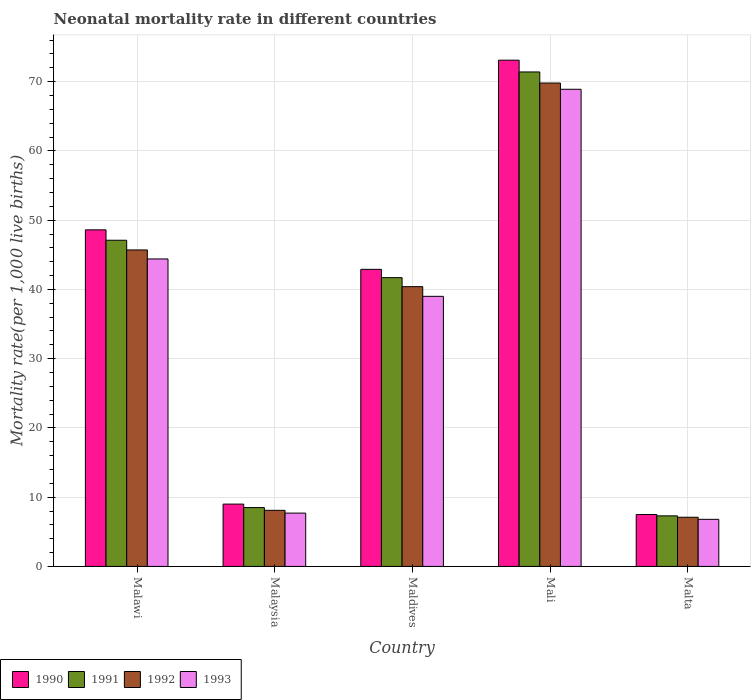How many groups of bars are there?
Your answer should be compact. 5. Are the number of bars per tick equal to the number of legend labels?
Ensure brevity in your answer.  Yes. How many bars are there on the 2nd tick from the left?
Offer a terse response. 4. How many bars are there on the 1st tick from the right?
Your answer should be very brief. 4. What is the label of the 2nd group of bars from the left?
Offer a terse response. Malaysia. What is the neonatal mortality rate in 1990 in Mali?
Your response must be concise. 73.1. Across all countries, what is the maximum neonatal mortality rate in 1990?
Make the answer very short. 73.1. In which country was the neonatal mortality rate in 1993 maximum?
Your answer should be compact. Mali. In which country was the neonatal mortality rate in 1991 minimum?
Ensure brevity in your answer.  Malta. What is the total neonatal mortality rate in 1992 in the graph?
Keep it short and to the point. 171.1. What is the difference between the neonatal mortality rate in 1990 in Malawi and that in Maldives?
Ensure brevity in your answer.  5.7. What is the difference between the neonatal mortality rate in 1991 in Maldives and the neonatal mortality rate in 1990 in Malaysia?
Keep it short and to the point. 32.7. What is the average neonatal mortality rate in 1992 per country?
Ensure brevity in your answer.  34.22. What is the difference between the neonatal mortality rate of/in 1990 and neonatal mortality rate of/in 1993 in Maldives?
Offer a terse response. 3.9. What is the ratio of the neonatal mortality rate in 1991 in Malawi to that in Malta?
Your response must be concise. 6.45. Is the difference between the neonatal mortality rate in 1990 in Malawi and Malaysia greater than the difference between the neonatal mortality rate in 1993 in Malawi and Malaysia?
Your answer should be very brief. Yes. What is the difference between the highest and the second highest neonatal mortality rate in 1992?
Your response must be concise. -5.3. What is the difference between the highest and the lowest neonatal mortality rate in 1991?
Provide a succinct answer. 64.1. In how many countries, is the neonatal mortality rate in 1991 greater than the average neonatal mortality rate in 1991 taken over all countries?
Offer a very short reply. 3. Is it the case that in every country, the sum of the neonatal mortality rate in 1991 and neonatal mortality rate in 1990 is greater than the sum of neonatal mortality rate in 1992 and neonatal mortality rate in 1993?
Your answer should be very brief. No. Is it the case that in every country, the sum of the neonatal mortality rate in 1990 and neonatal mortality rate in 1993 is greater than the neonatal mortality rate in 1992?
Ensure brevity in your answer.  Yes. How many bars are there?
Offer a very short reply. 20. Are the values on the major ticks of Y-axis written in scientific E-notation?
Your answer should be compact. No. Does the graph contain any zero values?
Your answer should be compact. No. Does the graph contain grids?
Your response must be concise. Yes. Where does the legend appear in the graph?
Give a very brief answer. Bottom left. What is the title of the graph?
Offer a very short reply. Neonatal mortality rate in different countries. Does "1997" appear as one of the legend labels in the graph?
Provide a short and direct response. No. What is the label or title of the X-axis?
Give a very brief answer. Country. What is the label or title of the Y-axis?
Offer a terse response. Mortality rate(per 1,0 live births). What is the Mortality rate(per 1,000 live births) in 1990 in Malawi?
Your answer should be compact. 48.6. What is the Mortality rate(per 1,000 live births) of 1991 in Malawi?
Provide a short and direct response. 47.1. What is the Mortality rate(per 1,000 live births) in 1992 in Malawi?
Make the answer very short. 45.7. What is the Mortality rate(per 1,000 live births) of 1993 in Malawi?
Ensure brevity in your answer.  44.4. What is the Mortality rate(per 1,000 live births) in 1990 in Malaysia?
Ensure brevity in your answer.  9. What is the Mortality rate(per 1,000 live births) of 1991 in Malaysia?
Keep it short and to the point. 8.5. What is the Mortality rate(per 1,000 live births) of 1993 in Malaysia?
Your answer should be compact. 7.7. What is the Mortality rate(per 1,000 live births) in 1990 in Maldives?
Your answer should be very brief. 42.9. What is the Mortality rate(per 1,000 live births) of 1991 in Maldives?
Offer a very short reply. 41.7. What is the Mortality rate(per 1,000 live births) in 1992 in Maldives?
Your response must be concise. 40.4. What is the Mortality rate(per 1,000 live births) of 1990 in Mali?
Offer a terse response. 73.1. What is the Mortality rate(per 1,000 live births) of 1991 in Mali?
Offer a very short reply. 71.4. What is the Mortality rate(per 1,000 live births) in 1992 in Mali?
Offer a terse response. 69.8. What is the Mortality rate(per 1,000 live births) of 1993 in Mali?
Offer a very short reply. 68.9. What is the Mortality rate(per 1,000 live births) in 1990 in Malta?
Offer a very short reply. 7.5. What is the Mortality rate(per 1,000 live births) in 1991 in Malta?
Ensure brevity in your answer.  7.3. What is the Mortality rate(per 1,000 live births) of 1993 in Malta?
Your response must be concise. 6.8. Across all countries, what is the maximum Mortality rate(per 1,000 live births) of 1990?
Your answer should be compact. 73.1. Across all countries, what is the maximum Mortality rate(per 1,000 live births) of 1991?
Your response must be concise. 71.4. Across all countries, what is the maximum Mortality rate(per 1,000 live births) in 1992?
Your response must be concise. 69.8. Across all countries, what is the maximum Mortality rate(per 1,000 live births) of 1993?
Offer a terse response. 68.9. Across all countries, what is the minimum Mortality rate(per 1,000 live births) of 1990?
Offer a terse response. 7.5. Across all countries, what is the minimum Mortality rate(per 1,000 live births) in 1991?
Provide a succinct answer. 7.3. What is the total Mortality rate(per 1,000 live births) of 1990 in the graph?
Offer a very short reply. 181.1. What is the total Mortality rate(per 1,000 live births) in 1991 in the graph?
Your answer should be compact. 176. What is the total Mortality rate(per 1,000 live births) of 1992 in the graph?
Provide a short and direct response. 171.1. What is the total Mortality rate(per 1,000 live births) in 1993 in the graph?
Offer a terse response. 166.8. What is the difference between the Mortality rate(per 1,000 live births) in 1990 in Malawi and that in Malaysia?
Provide a short and direct response. 39.6. What is the difference between the Mortality rate(per 1,000 live births) in 1991 in Malawi and that in Malaysia?
Your answer should be compact. 38.6. What is the difference between the Mortality rate(per 1,000 live births) of 1992 in Malawi and that in Malaysia?
Provide a succinct answer. 37.6. What is the difference between the Mortality rate(per 1,000 live births) of 1993 in Malawi and that in Malaysia?
Your answer should be compact. 36.7. What is the difference between the Mortality rate(per 1,000 live births) in 1990 in Malawi and that in Maldives?
Your response must be concise. 5.7. What is the difference between the Mortality rate(per 1,000 live births) of 1991 in Malawi and that in Maldives?
Make the answer very short. 5.4. What is the difference between the Mortality rate(per 1,000 live births) in 1992 in Malawi and that in Maldives?
Ensure brevity in your answer.  5.3. What is the difference between the Mortality rate(per 1,000 live births) of 1990 in Malawi and that in Mali?
Offer a very short reply. -24.5. What is the difference between the Mortality rate(per 1,000 live births) of 1991 in Malawi and that in Mali?
Your answer should be compact. -24.3. What is the difference between the Mortality rate(per 1,000 live births) of 1992 in Malawi and that in Mali?
Ensure brevity in your answer.  -24.1. What is the difference between the Mortality rate(per 1,000 live births) of 1993 in Malawi and that in Mali?
Ensure brevity in your answer.  -24.5. What is the difference between the Mortality rate(per 1,000 live births) of 1990 in Malawi and that in Malta?
Ensure brevity in your answer.  41.1. What is the difference between the Mortality rate(per 1,000 live births) in 1991 in Malawi and that in Malta?
Give a very brief answer. 39.8. What is the difference between the Mortality rate(per 1,000 live births) in 1992 in Malawi and that in Malta?
Offer a very short reply. 38.6. What is the difference between the Mortality rate(per 1,000 live births) in 1993 in Malawi and that in Malta?
Offer a terse response. 37.6. What is the difference between the Mortality rate(per 1,000 live births) of 1990 in Malaysia and that in Maldives?
Ensure brevity in your answer.  -33.9. What is the difference between the Mortality rate(per 1,000 live births) in 1991 in Malaysia and that in Maldives?
Make the answer very short. -33.2. What is the difference between the Mortality rate(per 1,000 live births) of 1992 in Malaysia and that in Maldives?
Make the answer very short. -32.3. What is the difference between the Mortality rate(per 1,000 live births) in 1993 in Malaysia and that in Maldives?
Keep it short and to the point. -31.3. What is the difference between the Mortality rate(per 1,000 live births) in 1990 in Malaysia and that in Mali?
Your answer should be very brief. -64.1. What is the difference between the Mortality rate(per 1,000 live births) of 1991 in Malaysia and that in Mali?
Ensure brevity in your answer.  -62.9. What is the difference between the Mortality rate(per 1,000 live births) of 1992 in Malaysia and that in Mali?
Give a very brief answer. -61.7. What is the difference between the Mortality rate(per 1,000 live births) of 1993 in Malaysia and that in Mali?
Your answer should be very brief. -61.2. What is the difference between the Mortality rate(per 1,000 live births) of 1990 in Malaysia and that in Malta?
Ensure brevity in your answer.  1.5. What is the difference between the Mortality rate(per 1,000 live births) of 1992 in Malaysia and that in Malta?
Provide a short and direct response. 1. What is the difference between the Mortality rate(per 1,000 live births) of 1993 in Malaysia and that in Malta?
Your answer should be very brief. 0.9. What is the difference between the Mortality rate(per 1,000 live births) in 1990 in Maldives and that in Mali?
Ensure brevity in your answer.  -30.2. What is the difference between the Mortality rate(per 1,000 live births) in 1991 in Maldives and that in Mali?
Keep it short and to the point. -29.7. What is the difference between the Mortality rate(per 1,000 live births) in 1992 in Maldives and that in Mali?
Make the answer very short. -29.4. What is the difference between the Mortality rate(per 1,000 live births) of 1993 in Maldives and that in Mali?
Make the answer very short. -29.9. What is the difference between the Mortality rate(per 1,000 live births) of 1990 in Maldives and that in Malta?
Keep it short and to the point. 35.4. What is the difference between the Mortality rate(per 1,000 live births) of 1991 in Maldives and that in Malta?
Make the answer very short. 34.4. What is the difference between the Mortality rate(per 1,000 live births) of 1992 in Maldives and that in Malta?
Offer a terse response. 33.3. What is the difference between the Mortality rate(per 1,000 live births) of 1993 in Maldives and that in Malta?
Your response must be concise. 32.2. What is the difference between the Mortality rate(per 1,000 live births) in 1990 in Mali and that in Malta?
Offer a very short reply. 65.6. What is the difference between the Mortality rate(per 1,000 live births) in 1991 in Mali and that in Malta?
Offer a very short reply. 64.1. What is the difference between the Mortality rate(per 1,000 live births) of 1992 in Mali and that in Malta?
Provide a short and direct response. 62.7. What is the difference between the Mortality rate(per 1,000 live births) of 1993 in Mali and that in Malta?
Provide a short and direct response. 62.1. What is the difference between the Mortality rate(per 1,000 live births) of 1990 in Malawi and the Mortality rate(per 1,000 live births) of 1991 in Malaysia?
Give a very brief answer. 40.1. What is the difference between the Mortality rate(per 1,000 live births) in 1990 in Malawi and the Mortality rate(per 1,000 live births) in 1992 in Malaysia?
Your answer should be compact. 40.5. What is the difference between the Mortality rate(per 1,000 live births) in 1990 in Malawi and the Mortality rate(per 1,000 live births) in 1993 in Malaysia?
Offer a terse response. 40.9. What is the difference between the Mortality rate(per 1,000 live births) of 1991 in Malawi and the Mortality rate(per 1,000 live births) of 1993 in Malaysia?
Your answer should be very brief. 39.4. What is the difference between the Mortality rate(per 1,000 live births) in 1992 in Malawi and the Mortality rate(per 1,000 live births) in 1993 in Malaysia?
Your answer should be compact. 38. What is the difference between the Mortality rate(per 1,000 live births) of 1990 in Malawi and the Mortality rate(per 1,000 live births) of 1992 in Maldives?
Ensure brevity in your answer.  8.2. What is the difference between the Mortality rate(per 1,000 live births) of 1990 in Malawi and the Mortality rate(per 1,000 live births) of 1993 in Maldives?
Your answer should be compact. 9.6. What is the difference between the Mortality rate(per 1,000 live births) in 1990 in Malawi and the Mortality rate(per 1,000 live births) in 1991 in Mali?
Offer a terse response. -22.8. What is the difference between the Mortality rate(per 1,000 live births) of 1990 in Malawi and the Mortality rate(per 1,000 live births) of 1992 in Mali?
Your answer should be very brief. -21.2. What is the difference between the Mortality rate(per 1,000 live births) in 1990 in Malawi and the Mortality rate(per 1,000 live births) in 1993 in Mali?
Your answer should be very brief. -20.3. What is the difference between the Mortality rate(per 1,000 live births) in 1991 in Malawi and the Mortality rate(per 1,000 live births) in 1992 in Mali?
Ensure brevity in your answer.  -22.7. What is the difference between the Mortality rate(per 1,000 live births) of 1991 in Malawi and the Mortality rate(per 1,000 live births) of 1993 in Mali?
Give a very brief answer. -21.8. What is the difference between the Mortality rate(per 1,000 live births) in 1992 in Malawi and the Mortality rate(per 1,000 live births) in 1993 in Mali?
Offer a terse response. -23.2. What is the difference between the Mortality rate(per 1,000 live births) of 1990 in Malawi and the Mortality rate(per 1,000 live births) of 1991 in Malta?
Ensure brevity in your answer.  41.3. What is the difference between the Mortality rate(per 1,000 live births) of 1990 in Malawi and the Mortality rate(per 1,000 live births) of 1992 in Malta?
Provide a short and direct response. 41.5. What is the difference between the Mortality rate(per 1,000 live births) of 1990 in Malawi and the Mortality rate(per 1,000 live births) of 1993 in Malta?
Make the answer very short. 41.8. What is the difference between the Mortality rate(per 1,000 live births) in 1991 in Malawi and the Mortality rate(per 1,000 live births) in 1993 in Malta?
Your response must be concise. 40.3. What is the difference between the Mortality rate(per 1,000 live births) in 1992 in Malawi and the Mortality rate(per 1,000 live births) in 1993 in Malta?
Make the answer very short. 38.9. What is the difference between the Mortality rate(per 1,000 live births) in 1990 in Malaysia and the Mortality rate(per 1,000 live births) in 1991 in Maldives?
Provide a succinct answer. -32.7. What is the difference between the Mortality rate(per 1,000 live births) in 1990 in Malaysia and the Mortality rate(per 1,000 live births) in 1992 in Maldives?
Make the answer very short. -31.4. What is the difference between the Mortality rate(per 1,000 live births) of 1991 in Malaysia and the Mortality rate(per 1,000 live births) of 1992 in Maldives?
Your answer should be very brief. -31.9. What is the difference between the Mortality rate(per 1,000 live births) in 1991 in Malaysia and the Mortality rate(per 1,000 live births) in 1993 in Maldives?
Your answer should be very brief. -30.5. What is the difference between the Mortality rate(per 1,000 live births) in 1992 in Malaysia and the Mortality rate(per 1,000 live births) in 1993 in Maldives?
Offer a very short reply. -30.9. What is the difference between the Mortality rate(per 1,000 live births) in 1990 in Malaysia and the Mortality rate(per 1,000 live births) in 1991 in Mali?
Your response must be concise. -62.4. What is the difference between the Mortality rate(per 1,000 live births) in 1990 in Malaysia and the Mortality rate(per 1,000 live births) in 1992 in Mali?
Your answer should be very brief. -60.8. What is the difference between the Mortality rate(per 1,000 live births) in 1990 in Malaysia and the Mortality rate(per 1,000 live births) in 1993 in Mali?
Give a very brief answer. -59.9. What is the difference between the Mortality rate(per 1,000 live births) of 1991 in Malaysia and the Mortality rate(per 1,000 live births) of 1992 in Mali?
Provide a short and direct response. -61.3. What is the difference between the Mortality rate(per 1,000 live births) of 1991 in Malaysia and the Mortality rate(per 1,000 live births) of 1993 in Mali?
Provide a short and direct response. -60.4. What is the difference between the Mortality rate(per 1,000 live births) in 1992 in Malaysia and the Mortality rate(per 1,000 live births) in 1993 in Mali?
Make the answer very short. -60.8. What is the difference between the Mortality rate(per 1,000 live births) of 1991 in Malaysia and the Mortality rate(per 1,000 live births) of 1993 in Malta?
Keep it short and to the point. 1.7. What is the difference between the Mortality rate(per 1,000 live births) of 1992 in Malaysia and the Mortality rate(per 1,000 live births) of 1993 in Malta?
Your answer should be compact. 1.3. What is the difference between the Mortality rate(per 1,000 live births) of 1990 in Maldives and the Mortality rate(per 1,000 live births) of 1991 in Mali?
Give a very brief answer. -28.5. What is the difference between the Mortality rate(per 1,000 live births) in 1990 in Maldives and the Mortality rate(per 1,000 live births) in 1992 in Mali?
Ensure brevity in your answer.  -26.9. What is the difference between the Mortality rate(per 1,000 live births) of 1990 in Maldives and the Mortality rate(per 1,000 live births) of 1993 in Mali?
Offer a very short reply. -26. What is the difference between the Mortality rate(per 1,000 live births) of 1991 in Maldives and the Mortality rate(per 1,000 live births) of 1992 in Mali?
Your response must be concise. -28.1. What is the difference between the Mortality rate(per 1,000 live births) of 1991 in Maldives and the Mortality rate(per 1,000 live births) of 1993 in Mali?
Ensure brevity in your answer.  -27.2. What is the difference between the Mortality rate(per 1,000 live births) of 1992 in Maldives and the Mortality rate(per 1,000 live births) of 1993 in Mali?
Your answer should be compact. -28.5. What is the difference between the Mortality rate(per 1,000 live births) in 1990 in Maldives and the Mortality rate(per 1,000 live births) in 1991 in Malta?
Offer a very short reply. 35.6. What is the difference between the Mortality rate(per 1,000 live births) in 1990 in Maldives and the Mortality rate(per 1,000 live births) in 1992 in Malta?
Your answer should be compact. 35.8. What is the difference between the Mortality rate(per 1,000 live births) in 1990 in Maldives and the Mortality rate(per 1,000 live births) in 1993 in Malta?
Give a very brief answer. 36.1. What is the difference between the Mortality rate(per 1,000 live births) in 1991 in Maldives and the Mortality rate(per 1,000 live births) in 1992 in Malta?
Make the answer very short. 34.6. What is the difference between the Mortality rate(per 1,000 live births) in 1991 in Maldives and the Mortality rate(per 1,000 live births) in 1993 in Malta?
Ensure brevity in your answer.  34.9. What is the difference between the Mortality rate(per 1,000 live births) in 1992 in Maldives and the Mortality rate(per 1,000 live births) in 1993 in Malta?
Provide a short and direct response. 33.6. What is the difference between the Mortality rate(per 1,000 live births) in 1990 in Mali and the Mortality rate(per 1,000 live births) in 1991 in Malta?
Give a very brief answer. 65.8. What is the difference between the Mortality rate(per 1,000 live births) of 1990 in Mali and the Mortality rate(per 1,000 live births) of 1993 in Malta?
Offer a very short reply. 66.3. What is the difference between the Mortality rate(per 1,000 live births) in 1991 in Mali and the Mortality rate(per 1,000 live births) in 1992 in Malta?
Offer a terse response. 64.3. What is the difference between the Mortality rate(per 1,000 live births) of 1991 in Mali and the Mortality rate(per 1,000 live births) of 1993 in Malta?
Keep it short and to the point. 64.6. What is the difference between the Mortality rate(per 1,000 live births) of 1992 in Mali and the Mortality rate(per 1,000 live births) of 1993 in Malta?
Provide a short and direct response. 63. What is the average Mortality rate(per 1,000 live births) of 1990 per country?
Provide a succinct answer. 36.22. What is the average Mortality rate(per 1,000 live births) in 1991 per country?
Give a very brief answer. 35.2. What is the average Mortality rate(per 1,000 live births) in 1992 per country?
Keep it short and to the point. 34.22. What is the average Mortality rate(per 1,000 live births) in 1993 per country?
Your answer should be compact. 33.36. What is the difference between the Mortality rate(per 1,000 live births) of 1991 and Mortality rate(per 1,000 live births) of 1992 in Malawi?
Your answer should be very brief. 1.4. What is the difference between the Mortality rate(per 1,000 live births) of 1991 and Mortality rate(per 1,000 live births) of 1993 in Malawi?
Provide a short and direct response. 2.7. What is the difference between the Mortality rate(per 1,000 live births) in 1992 and Mortality rate(per 1,000 live births) in 1993 in Malawi?
Give a very brief answer. 1.3. What is the difference between the Mortality rate(per 1,000 live births) in 1990 and Mortality rate(per 1,000 live births) in 1991 in Malaysia?
Give a very brief answer. 0.5. What is the difference between the Mortality rate(per 1,000 live births) of 1990 and Mortality rate(per 1,000 live births) of 1993 in Malaysia?
Your answer should be compact. 1.3. What is the difference between the Mortality rate(per 1,000 live births) of 1991 and Mortality rate(per 1,000 live births) of 1992 in Malaysia?
Make the answer very short. 0.4. What is the difference between the Mortality rate(per 1,000 live births) of 1991 and Mortality rate(per 1,000 live births) of 1993 in Malaysia?
Your response must be concise. 0.8. What is the difference between the Mortality rate(per 1,000 live births) in 1992 and Mortality rate(per 1,000 live births) in 1993 in Malaysia?
Your answer should be very brief. 0.4. What is the difference between the Mortality rate(per 1,000 live births) of 1990 and Mortality rate(per 1,000 live births) of 1991 in Maldives?
Keep it short and to the point. 1.2. What is the difference between the Mortality rate(per 1,000 live births) in 1991 and Mortality rate(per 1,000 live births) in 1993 in Maldives?
Keep it short and to the point. 2.7. What is the difference between the Mortality rate(per 1,000 live births) of 1990 and Mortality rate(per 1,000 live births) of 1991 in Mali?
Ensure brevity in your answer.  1.7. What is the difference between the Mortality rate(per 1,000 live births) of 1991 and Mortality rate(per 1,000 live births) of 1992 in Mali?
Your answer should be compact. 1.6. What is the difference between the Mortality rate(per 1,000 live births) of 1991 and Mortality rate(per 1,000 live births) of 1993 in Mali?
Your response must be concise. 2.5. What is the difference between the Mortality rate(per 1,000 live births) in 1992 and Mortality rate(per 1,000 live births) in 1993 in Mali?
Give a very brief answer. 0.9. What is the difference between the Mortality rate(per 1,000 live births) of 1991 and Mortality rate(per 1,000 live births) of 1992 in Malta?
Make the answer very short. 0.2. What is the difference between the Mortality rate(per 1,000 live births) of 1991 and Mortality rate(per 1,000 live births) of 1993 in Malta?
Give a very brief answer. 0.5. What is the ratio of the Mortality rate(per 1,000 live births) of 1991 in Malawi to that in Malaysia?
Make the answer very short. 5.54. What is the ratio of the Mortality rate(per 1,000 live births) of 1992 in Malawi to that in Malaysia?
Your answer should be compact. 5.64. What is the ratio of the Mortality rate(per 1,000 live births) of 1993 in Malawi to that in Malaysia?
Provide a succinct answer. 5.77. What is the ratio of the Mortality rate(per 1,000 live births) in 1990 in Malawi to that in Maldives?
Keep it short and to the point. 1.13. What is the ratio of the Mortality rate(per 1,000 live births) of 1991 in Malawi to that in Maldives?
Provide a succinct answer. 1.13. What is the ratio of the Mortality rate(per 1,000 live births) in 1992 in Malawi to that in Maldives?
Provide a succinct answer. 1.13. What is the ratio of the Mortality rate(per 1,000 live births) of 1993 in Malawi to that in Maldives?
Your response must be concise. 1.14. What is the ratio of the Mortality rate(per 1,000 live births) of 1990 in Malawi to that in Mali?
Make the answer very short. 0.66. What is the ratio of the Mortality rate(per 1,000 live births) in 1991 in Malawi to that in Mali?
Give a very brief answer. 0.66. What is the ratio of the Mortality rate(per 1,000 live births) in 1992 in Malawi to that in Mali?
Your answer should be very brief. 0.65. What is the ratio of the Mortality rate(per 1,000 live births) in 1993 in Malawi to that in Mali?
Give a very brief answer. 0.64. What is the ratio of the Mortality rate(per 1,000 live births) in 1990 in Malawi to that in Malta?
Your answer should be very brief. 6.48. What is the ratio of the Mortality rate(per 1,000 live births) of 1991 in Malawi to that in Malta?
Make the answer very short. 6.45. What is the ratio of the Mortality rate(per 1,000 live births) in 1992 in Malawi to that in Malta?
Give a very brief answer. 6.44. What is the ratio of the Mortality rate(per 1,000 live births) in 1993 in Malawi to that in Malta?
Provide a short and direct response. 6.53. What is the ratio of the Mortality rate(per 1,000 live births) of 1990 in Malaysia to that in Maldives?
Give a very brief answer. 0.21. What is the ratio of the Mortality rate(per 1,000 live births) of 1991 in Malaysia to that in Maldives?
Keep it short and to the point. 0.2. What is the ratio of the Mortality rate(per 1,000 live births) of 1992 in Malaysia to that in Maldives?
Provide a short and direct response. 0.2. What is the ratio of the Mortality rate(per 1,000 live births) in 1993 in Malaysia to that in Maldives?
Provide a succinct answer. 0.2. What is the ratio of the Mortality rate(per 1,000 live births) in 1990 in Malaysia to that in Mali?
Provide a short and direct response. 0.12. What is the ratio of the Mortality rate(per 1,000 live births) in 1991 in Malaysia to that in Mali?
Ensure brevity in your answer.  0.12. What is the ratio of the Mortality rate(per 1,000 live births) of 1992 in Malaysia to that in Mali?
Keep it short and to the point. 0.12. What is the ratio of the Mortality rate(per 1,000 live births) in 1993 in Malaysia to that in Mali?
Offer a terse response. 0.11. What is the ratio of the Mortality rate(per 1,000 live births) in 1990 in Malaysia to that in Malta?
Your response must be concise. 1.2. What is the ratio of the Mortality rate(per 1,000 live births) of 1991 in Malaysia to that in Malta?
Make the answer very short. 1.16. What is the ratio of the Mortality rate(per 1,000 live births) in 1992 in Malaysia to that in Malta?
Make the answer very short. 1.14. What is the ratio of the Mortality rate(per 1,000 live births) of 1993 in Malaysia to that in Malta?
Provide a succinct answer. 1.13. What is the ratio of the Mortality rate(per 1,000 live births) of 1990 in Maldives to that in Mali?
Your response must be concise. 0.59. What is the ratio of the Mortality rate(per 1,000 live births) in 1991 in Maldives to that in Mali?
Provide a short and direct response. 0.58. What is the ratio of the Mortality rate(per 1,000 live births) in 1992 in Maldives to that in Mali?
Your answer should be very brief. 0.58. What is the ratio of the Mortality rate(per 1,000 live births) in 1993 in Maldives to that in Mali?
Your response must be concise. 0.57. What is the ratio of the Mortality rate(per 1,000 live births) in 1990 in Maldives to that in Malta?
Your answer should be very brief. 5.72. What is the ratio of the Mortality rate(per 1,000 live births) in 1991 in Maldives to that in Malta?
Your answer should be compact. 5.71. What is the ratio of the Mortality rate(per 1,000 live births) of 1992 in Maldives to that in Malta?
Make the answer very short. 5.69. What is the ratio of the Mortality rate(per 1,000 live births) in 1993 in Maldives to that in Malta?
Give a very brief answer. 5.74. What is the ratio of the Mortality rate(per 1,000 live births) in 1990 in Mali to that in Malta?
Offer a terse response. 9.75. What is the ratio of the Mortality rate(per 1,000 live births) in 1991 in Mali to that in Malta?
Offer a very short reply. 9.78. What is the ratio of the Mortality rate(per 1,000 live births) of 1992 in Mali to that in Malta?
Keep it short and to the point. 9.83. What is the ratio of the Mortality rate(per 1,000 live births) in 1993 in Mali to that in Malta?
Ensure brevity in your answer.  10.13. What is the difference between the highest and the second highest Mortality rate(per 1,000 live births) in 1991?
Provide a short and direct response. 24.3. What is the difference between the highest and the second highest Mortality rate(per 1,000 live births) in 1992?
Ensure brevity in your answer.  24.1. What is the difference between the highest and the lowest Mortality rate(per 1,000 live births) in 1990?
Ensure brevity in your answer.  65.6. What is the difference between the highest and the lowest Mortality rate(per 1,000 live births) in 1991?
Your answer should be compact. 64.1. What is the difference between the highest and the lowest Mortality rate(per 1,000 live births) of 1992?
Provide a short and direct response. 62.7. What is the difference between the highest and the lowest Mortality rate(per 1,000 live births) of 1993?
Offer a very short reply. 62.1. 